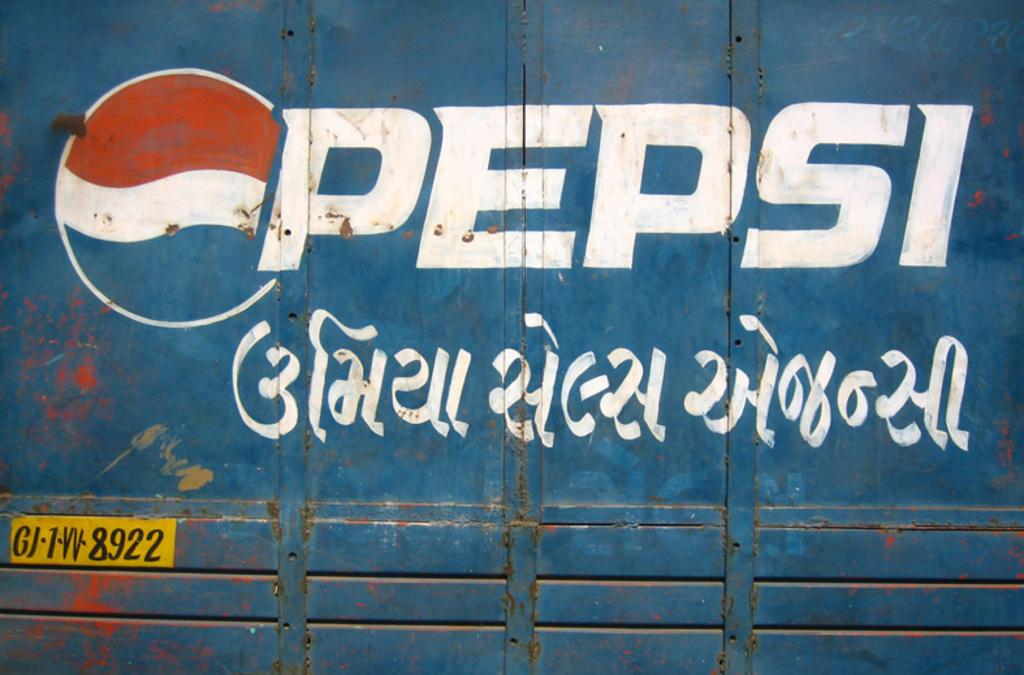What company is this?
Make the answer very short. Pepsi. The last four numbers in the yellow box are?
Your answer should be compact. 8922. 